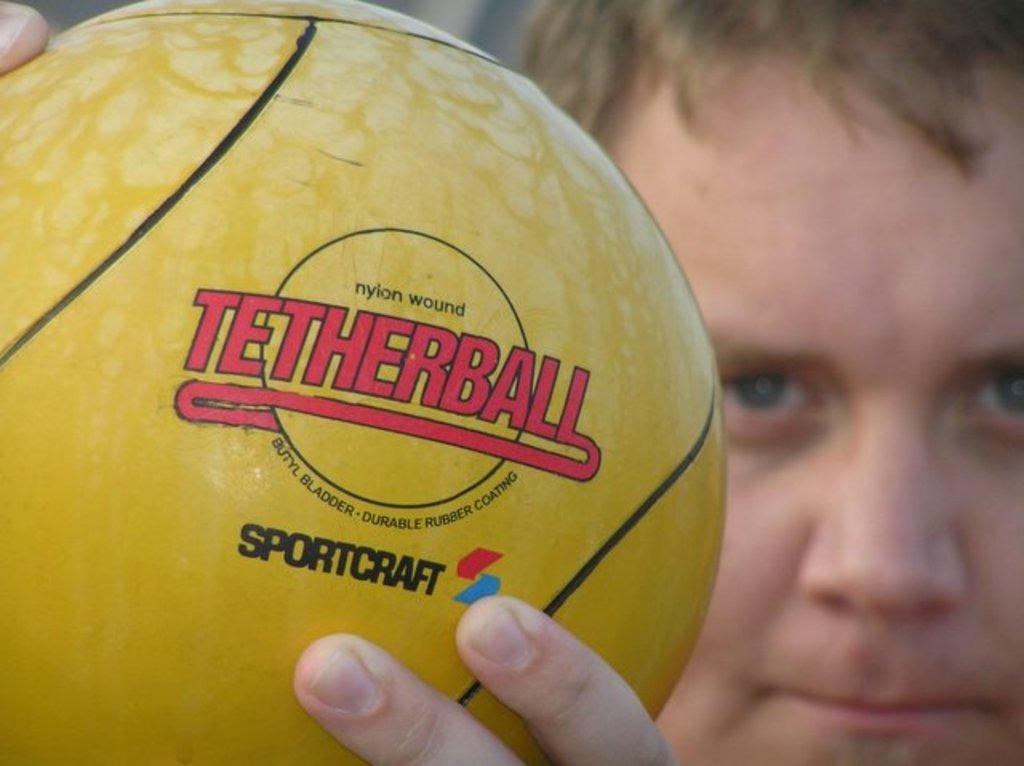<image>
Relay a brief, clear account of the picture shown. a close up of a yellow Tetherball held in someone's hands 